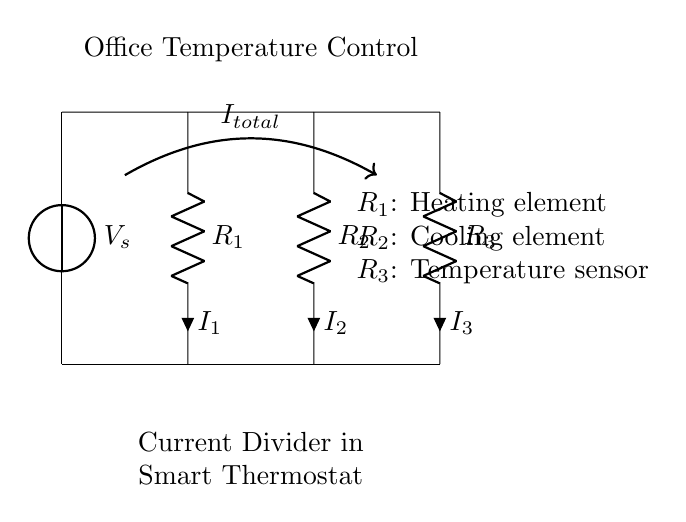What is the total current in the circuit? The total current can be represented as \(I_{total}\), which is shown in the circuit diagram as an arrow labeled with that term.
Answer: I total What are the three resistors in this circuit? The circuit contains three resistors labeled as R1, R2, and R3. Resistor R1 is the heating element, R2 is the cooling element, and R3 is the temperature sensor.
Answer: R1, R2, R3 What type of circuit is shown here? The circuit is a current divider circuit, as indicated by the arrangement of the resistors in parallel, which divides the total current into smaller currents through each resistor.
Answer: Current divider How are the resistors connected in this circuit? The resistors R1, R2, and R3 are connected in parallel, as they all share the same voltage across them from the voltage source and the total current splits among them.
Answer: Parallel What happens to the current if one resistor fails? If one resistor fails, the total current will redistribute among the remaining resistors, affecting the current through each of them based on their resistance values.
Answer: Redistributes What components are represented in the circuit besides resistors? Besides resistors, the circuit includes a voltage source (represented as V_s), which provides the electrical energy needed for the circuit to function.
Answer: Voltage source 